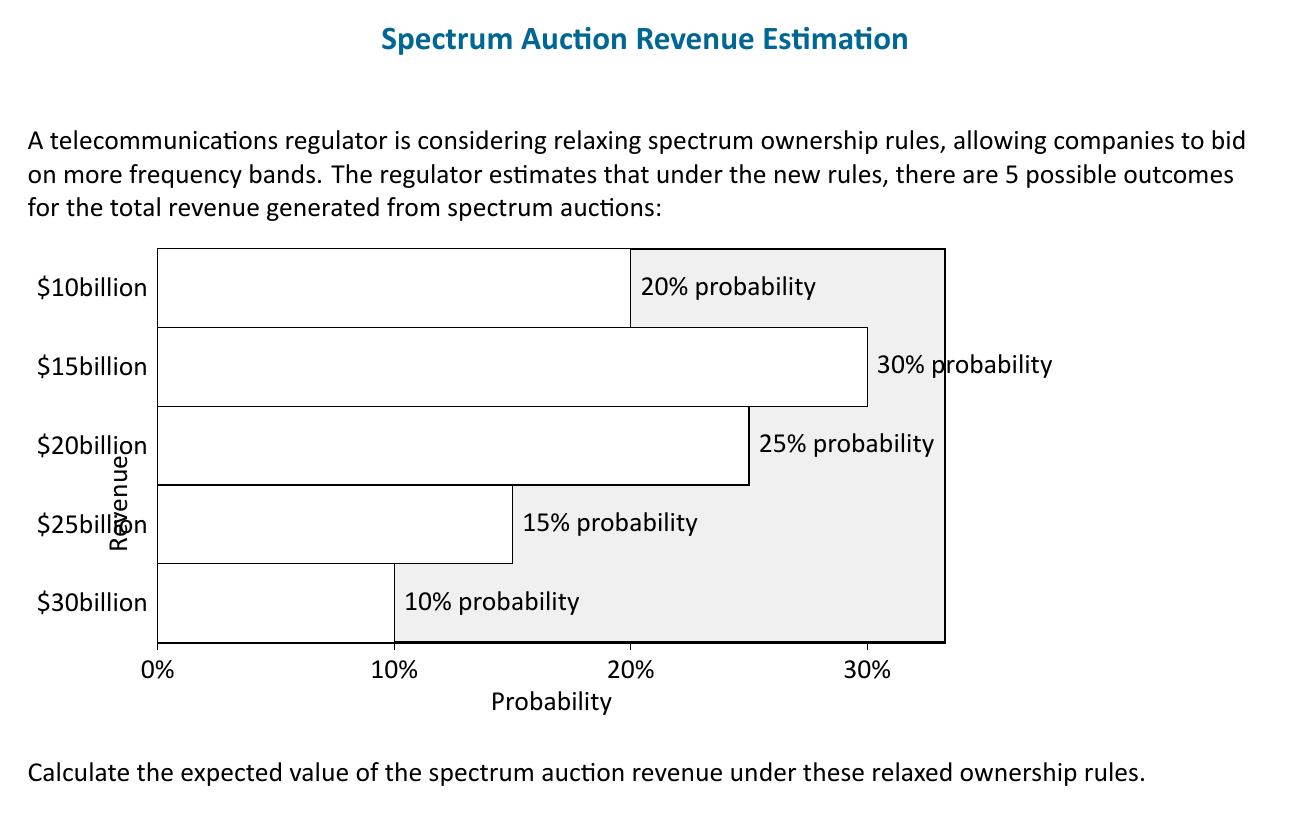What is the answer to this math problem? To calculate the expected value, we need to multiply each possible outcome by its probability and then sum these products. Let's break it down step-by-step:

1) First, let's convert the probabilities to decimals:
   20% = 0.20
   30% = 0.30
   25% = 0.25
   15% = 0.15
   10% = 0.10

2) Now, let's multiply each outcome by its probability:
   $10 billion * 0.20 = $2 billion
   $15 billion * 0.30 = $4.5 billion
   $20 billion * 0.25 = $5 billion
   $25 billion * 0.15 = $3.75 billion
   $30 billion * 0.10 = $3 billion

3) The expected value is the sum of these products:

   $$E = (10 * 0.20) + (15 * 0.30) + (20 * 0.25) + (25 * 0.15) + (30 * 0.10)$$
   $$E = 2 + 4.5 + 5 + 3.75 + 3$$
   $$E = 18.25$$

Therefore, the expected value of the spectrum auction revenue under the relaxed ownership rules is $18.25 billion.
Answer: $18.25 billion 